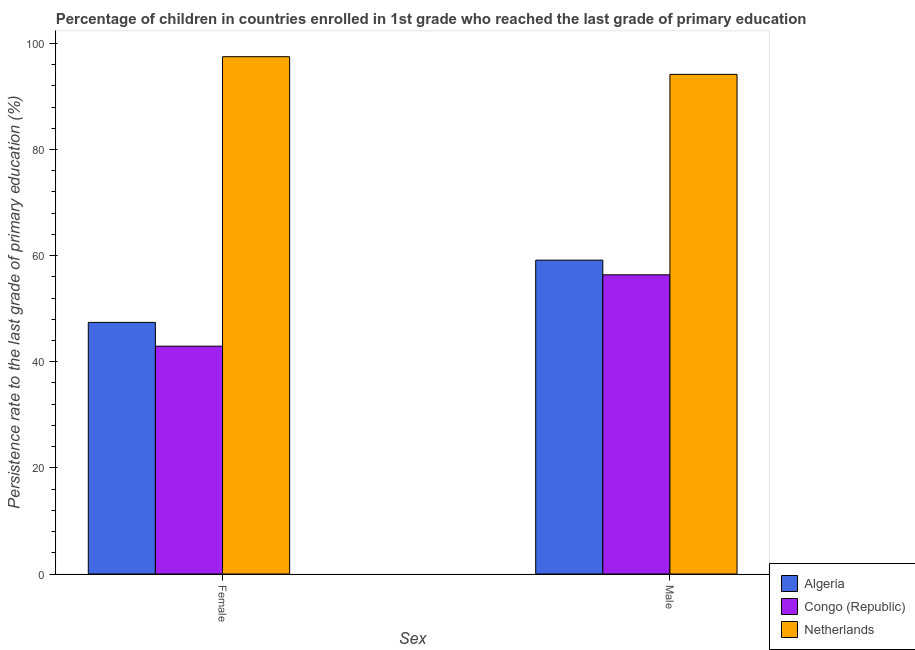Are the number of bars per tick equal to the number of legend labels?
Keep it short and to the point. Yes. How many bars are there on the 1st tick from the left?
Your response must be concise. 3. What is the label of the 2nd group of bars from the left?
Ensure brevity in your answer.  Male. What is the persistence rate of female students in Algeria?
Your answer should be very brief. 47.41. Across all countries, what is the maximum persistence rate of female students?
Offer a very short reply. 97.49. Across all countries, what is the minimum persistence rate of male students?
Ensure brevity in your answer.  56.38. In which country was the persistence rate of male students minimum?
Provide a short and direct response. Congo (Republic). What is the total persistence rate of female students in the graph?
Your answer should be compact. 187.84. What is the difference between the persistence rate of male students in Algeria and that in Netherlands?
Offer a very short reply. -35.01. What is the difference between the persistence rate of male students in Congo (Republic) and the persistence rate of female students in Algeria?
Give a very brief answer. 8.97. What is the average persistence rate of female students per country?
Make the answer very short. 62.61. What is the difference between the persistence rate of female students and persistence rate of male students in Netherlands?
Provide a succinct answer. 3.33. What is the ratio of the persistence rate of female students in Algeria to that in Netherlands?
Your answer should be very brief. 0.49. Is the persistence rate of male students in Congo (Republic) less than that in Netherlands?
Make the answer very short. Yes. What does the 1st bar from the left in Male represents?
Provide a succinct answer. Algeria. What does the 1st bar from the right in Female represents?
Ensure brevity in your answer.  Netherlands. How many bars are there?
Make the answer very short. 6. What is the difference between two consecutive major ticks on the Y-axis?
Provide a short and direct response. 20. Are the values on the major ticks of Y-axis written in scientific E-notation?
Your response must be concise. No. Does the graph contain any zero values?
Offer a terse response. No. How many legend labels are there?
Ensure brevity in your answer.  3. How are the legend labels stacked?
Ensure brevity in your answer.  Vertical. What is the title of the graph?
Your response must be concise. Percentage of children in countries enrolled in 1st grade who reached the last grade of primary education. Does "Benin" appear as one of the legend labels in the graph?
Offer a very short reply. No. What is the label or title of the X-axis?
Make the answer very short. Sex. What is the label or title of the Y-axis?
Ensure brevity in your answer.  Persistence rate to the last grade of primary education (%). What is the Persistence rate to the last grade of primary education (%) in Algeria in Female?
Your answer should be compact. 47.41. What is the Persistence rate to the last grade of primary education (%) in Congo (Republic) in Female?
Ensure brevity in your answer.  42.94. What is the Persistence rate to the last grade of primary education (%) in Netherlands in Female?
Give a very brief answer. 97.49. What is the Persistence rate to the last grade of primary education (%) of Algeria in Male?
Offer a very short reply. 59.15. What is the Persistence rate to the last grade of primary education (%) in Congo (Republic) in Male?
Your response must be concise. 56.38. What is the Persistence rate to the last grade of primary education (%) of Netherlands in Male?
Ensure brevity in your answer.  94.16. Across all Sex, what is the maximum Persistence rate to the last grade of primary education (%) of Algeria?
Offer a terse response. 59.15. Across all Sex, what is the maximum Persistence rate to the last grade of primary education (%) of Congo (Republic)?
Provide a short and direct response. 56.38. Across all Sex, what is the maximum Persistence rate to the last grade of primary education (%) in Netherlands?
Provide a succinct answer. 97.49. Across all Sex, what is the minimum Persistence rate to the last grade of primary education (%) in Algeria?
Provide a short and direct response. 47.41. Across all Sex, what is the minimum Persistence rate to the last grade of primary education (%) in Congo (Republic)?
Your answer should be very brief. 42.94. Across all Sex, what is the minimum Persistence rate to the last grade of primary education (%) in Netherlands?
Your answer should be compact. 94.16. What is the total Persistence rate to the last grade of primary education (%) in Algeria in the graph?
Give a very brief answer. 106.56. What is the total Persistence rate to the last grade of primary education (%) in Congo (Republic) in the graph?
Offer a very short reply. 99.32. What is the total Persistence rate to the last grade of primary education (%) of Netherlands in the graph?
Offer a terse response. 191.64. What is the difference between the Persistence rate to the last grade of primary education (%) of Algeria in Female and that in Male?
Your answer should be very brief. -11.73. What is the difference between the Persistence rate to the last grade of primary education (%) in Congo (Republic) in Female and that in Male?
Your answer should be compact. -13.45. What is the difference between the Persistence rate to the last grade of primary education (%) in Netherlands in Female and that in Male?
Keep it short and to the point. 3.33. What is the difference between the Persistence rate to the last grade of primary education (%) in Algeria in Female and the Persistence rate to the last grade of primary education (%) in Congo (Republic) in Male?
Your answer should be very brief. -8.97. What is the difference between the Persistence rate to the last grade of primary education (%) of Algeria in Female and the Persistence rate to the last grade of primary education (%) of Netherlands in Male?
Your answer should be very brief. -46.74. What is the difference between the Persistence rate to the last grade of primary education (%) of Congo (Republic) in Female and the Persistence rate to the last grade of primary education (%) of Netherlands in Male?
Provide a succinct answer. -51.22. What is the average Persistence rate to the last grade of primary education (%) of Algeria per Sex?
Make the answer very short. 53.28. What is the average Persistence rate to the last grade of primary education (%) in Congo (Republic) per Sex?
Keep it short and to the point. 49.66. What is the average Persistence rate to the last grade of primary education (%) in Netherlands per Sex?
Ensure brevity in your answer.  95.82. What is the difference between the Persistence rate to the last grade of primary education (%) in Algeria and Persistence rate to the last grade of primary education (%) in Congo (Republic) in Female?
Your answer should be very brief. 4.48. What is the difference between the Persistence rate to the last grade of primary education (%) in Algeria and Persistence rate to the last grade of primary education (%) in Netherlands in Female?
Keep it short and to the point. -50.07. What is the difference between the Persistence rate to the last grade of primary education (%) in Congo (Republic) and Persistence rate to the last grade of primary education (%) in Netherlands in Female?
Ensure brevity in your answer.  -54.55. What is the difference between the Persistence rate to the last grade of primary education (%) in Algeria and Persistence rate to the last grade of primary education (%) in Congo (Republic) in Male?
Give a very brief answer. 2.76. What is the difference between the Persistence rate to the last grade of primary education (%) of Algeria and Persistence rate to the last grade of primary education (%) of Netherlands in Male?
Make the answer very short. -35.01. What is the difference between the Persistence rate to the last grade of primary education (%) in Congo (Republic) and Persistence rate to the last grade of primary education (%) in Netherlands in Male?
Your response must be concise. -37.77. What is the ratio of the Persistence rate to the last grade of primary education (%) of Algeria in Female to that in Male?
Offer a very short reply. 0.8. What is the ratio of the Persistence rate to the last grade of primary education (%) of Congo (Republic) in Female to that in Male?
Give a very brief answer. 0.76. What is the ratio of the Persistence rate to the last grade of primary education (%) in Netherlands in Female to that in Male?
Offer a terse response. 1.04. What is the difference between the highest and the second highest Persistence rate to the last grade of primary education (%) of Algeria?
Offer a terse response. 11.73. What is the difference between the highest and the second highest Persistence rate to the last grade of primary education (%) of Congo (Republic)?
Your answer should be compact. 13.45. What is the difference between the highest and the second highest Persistence rate to the last grade of primary education (%) of Netherlands?
Make the answer very short. 3.33. What is the difference between the highest and the lowest Persistence rate to the last grade of primary education (%) in Algeria?
Ensure brevity in your answer.  11.73. What is the difference between the highest and the lowest Persistence rate to the last grade of primary education (%) in Congo (Republic)?
Keep it short and to the point. 13.45. What is the difference between the highest and the lowest Persistence rate to the last grade of primary education (%) in Netherlands?
Give a very brief answer. 3.33. 